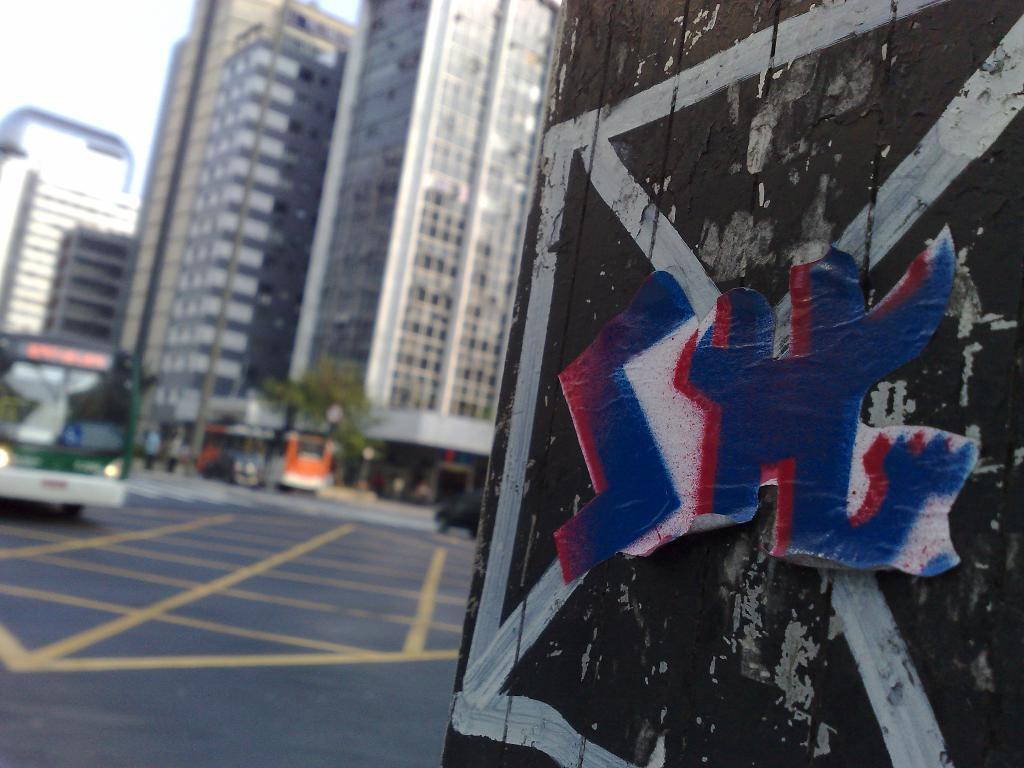What is depicted on the wall in the image? There is a painting on the wall in the image. What else is on the wall besides the painting? There is a sticker on the wall. What can be seen in the background of the image? There are buildings, trees, persons, and vehicles on the road in the background of the image. What type of grain is visible in the image? There is no grain present in the image. How does the connection between the persons in the background of the image appear? The image does not show a direct connection between the persons in the background; they are simply present in the same scene. 